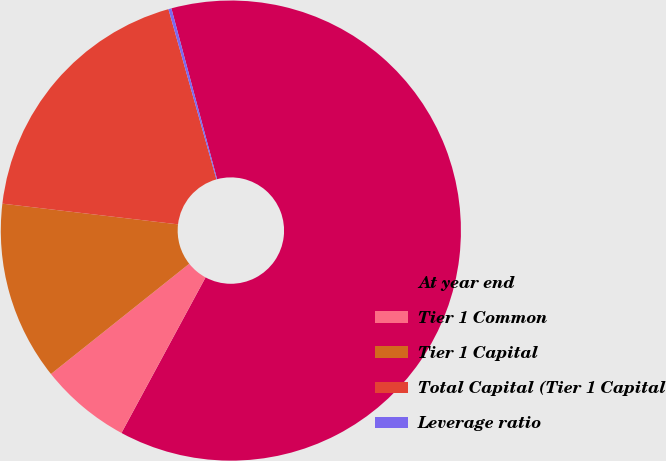<chart> <loc_0><loc_0><loc_500><loc_500><pie_chart><fcel>At year end<fcel>Tier 1 Common<fcel>Tier 1 Capital<fcel>Total Capital (Tier 1 Capital<fcel>Leverage ratio<nl><fcel>62.05%<fcel>6.4%<fcel>12.58%<fcel>18.76%<fcel>0.21%<nl></chart> 